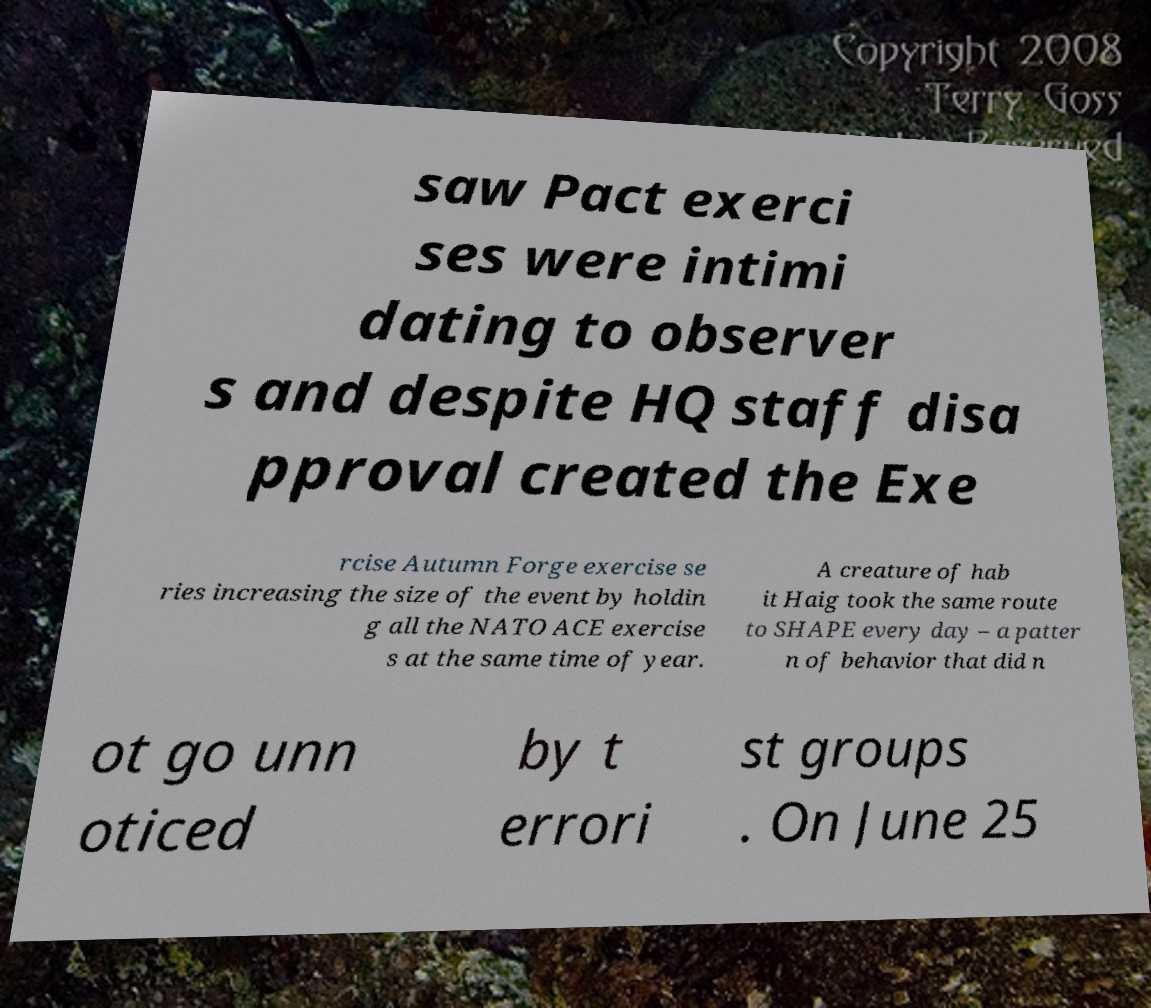What messages or text are displayed in this image? I need them in a readable, typed format. saw Pact exerci ses were intimi dating to observer s and despite HQ staff disa pproval created the Exe rcise Autumn Forge exercise se ries increasing the size of the event by holdin g all the NATO ACE exercise s at the same time of year. A creature of hab it Haig took the same route to SHAPE every day – a patter n of behavior that did n ot go unn oticed by t errori st groups . On June 25 